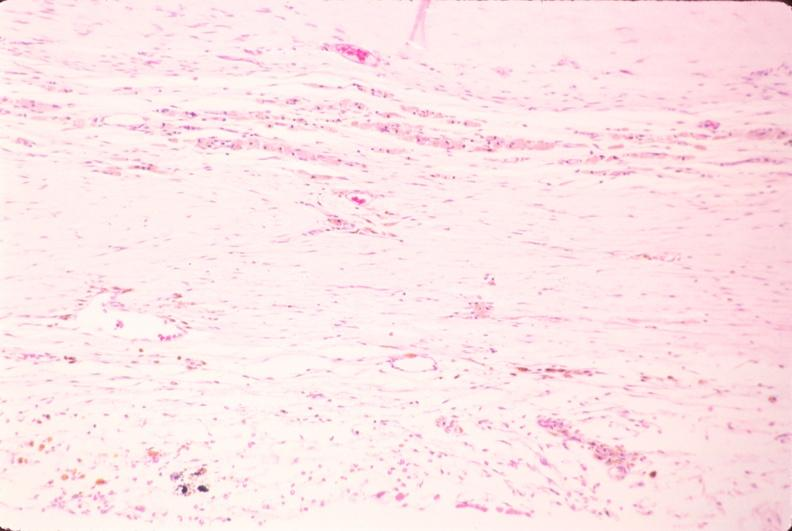where is this?
Answer the question using a single word or phrase. Nervous 